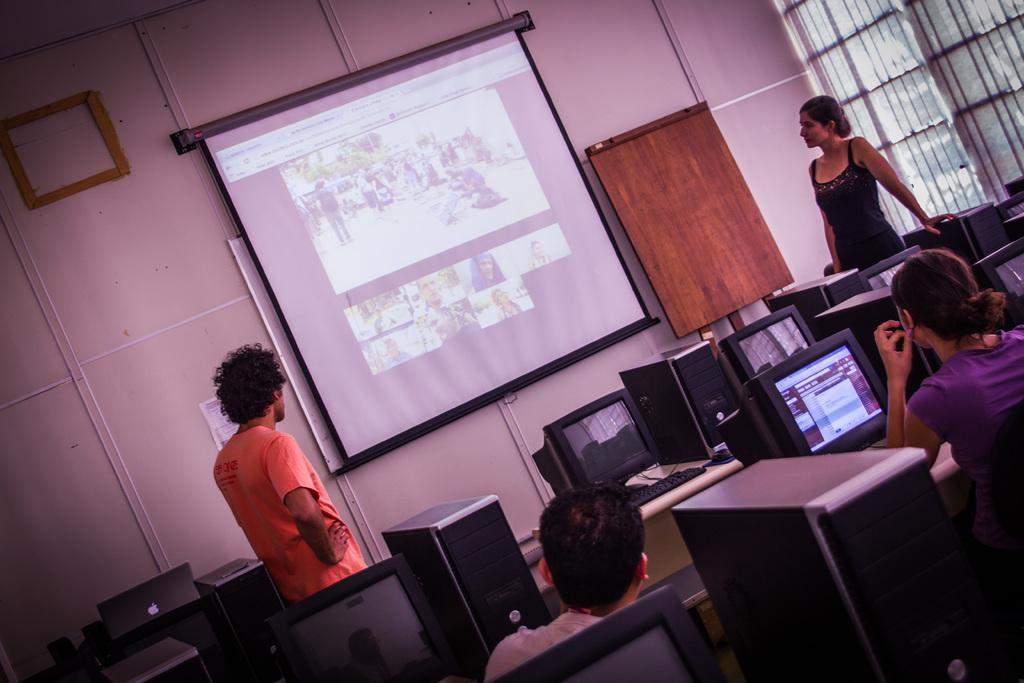What type of equipment can be seen in the image? There are systems, keyboards, mice, CPU units, and a screen visible in the image. What is the purpose of the equipment in the image? The equipment in the image is likely used for computing or technology-related tasks. How many people are present in the image? Two people are standing in the image. What is the background of the image? There is a wall in the image. What type of animals can be seen at the zoo in the image? There is no zoo or animals present in the image; it features technology equipment and people. What type of shock can be seen affecting the equipment in the image? There is no shock or electrical disturbance visible in the image; the equipment appears to be functioning normally. 